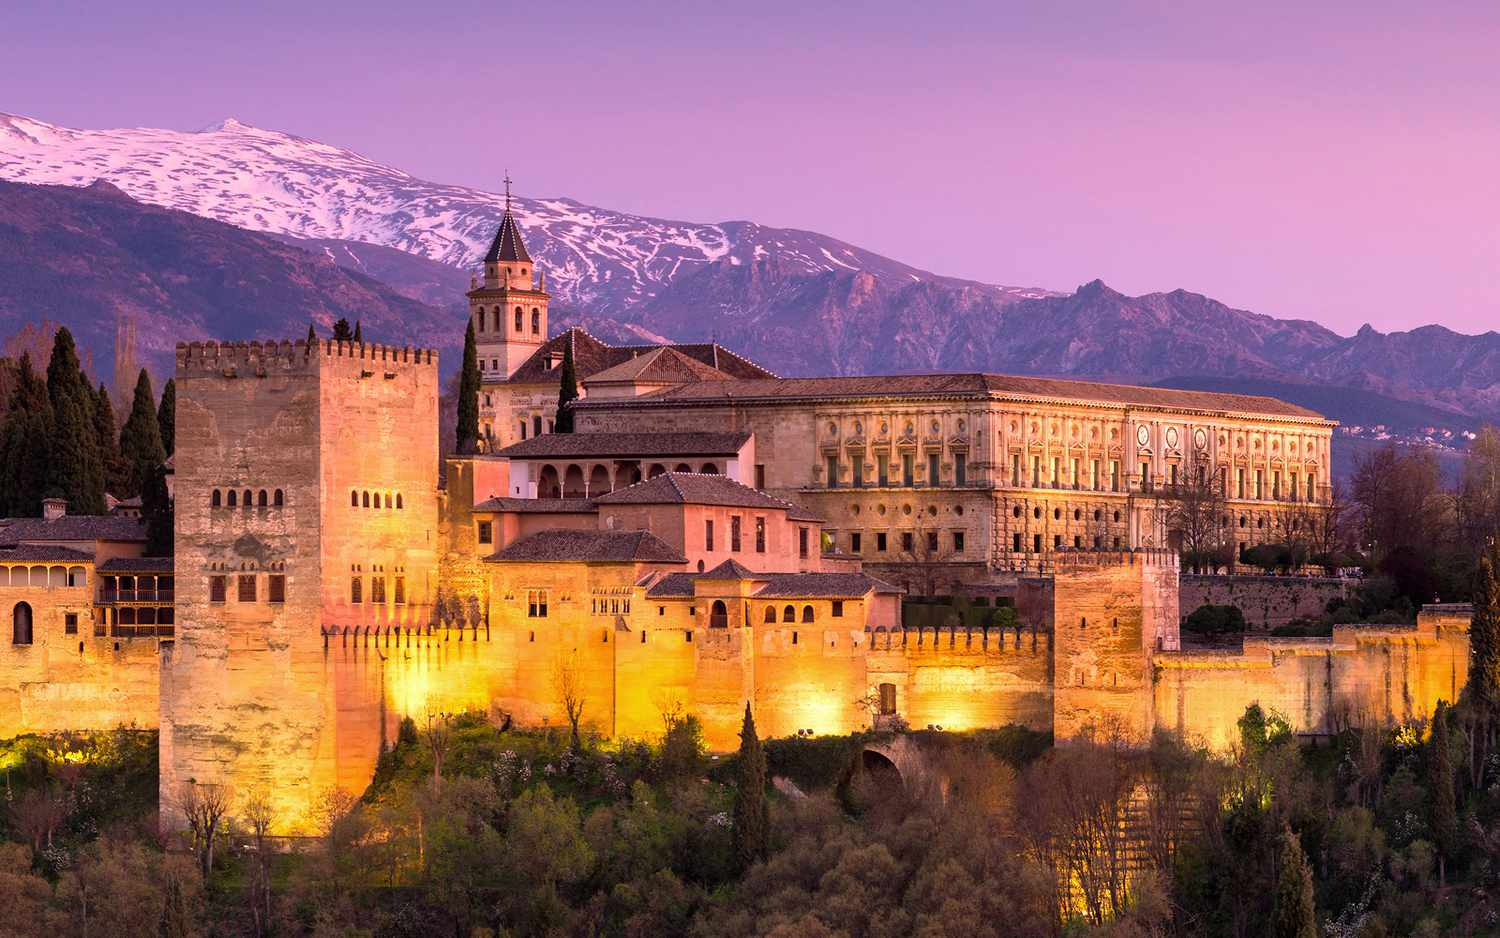What's happening in the scene? This enchanting image unfolds at dusk, capturing the moment when the Alhambra—a symbol of historical grandeur in Granada, Spain—transitions into a luminous wonder. As day gives way to night, the walls of the fortress complex glow with an inviting warm light, offering a stark contrast to the cool, fading light of the sky. The sprawling complex with its palaces, courtyards, and gardens, is backdropped by the majestic Sierra Nevada mountains, dappled with the last hints of snow, suggesting both the fortress's strategic defensive position and its harmonious existence with nature. The elevated vantage point of this shot reveals not just the magnificent scale of the Alhambra, but also invites the viewer to appreciate its enduring legacy in the fabric of Andalusian history and culture. 